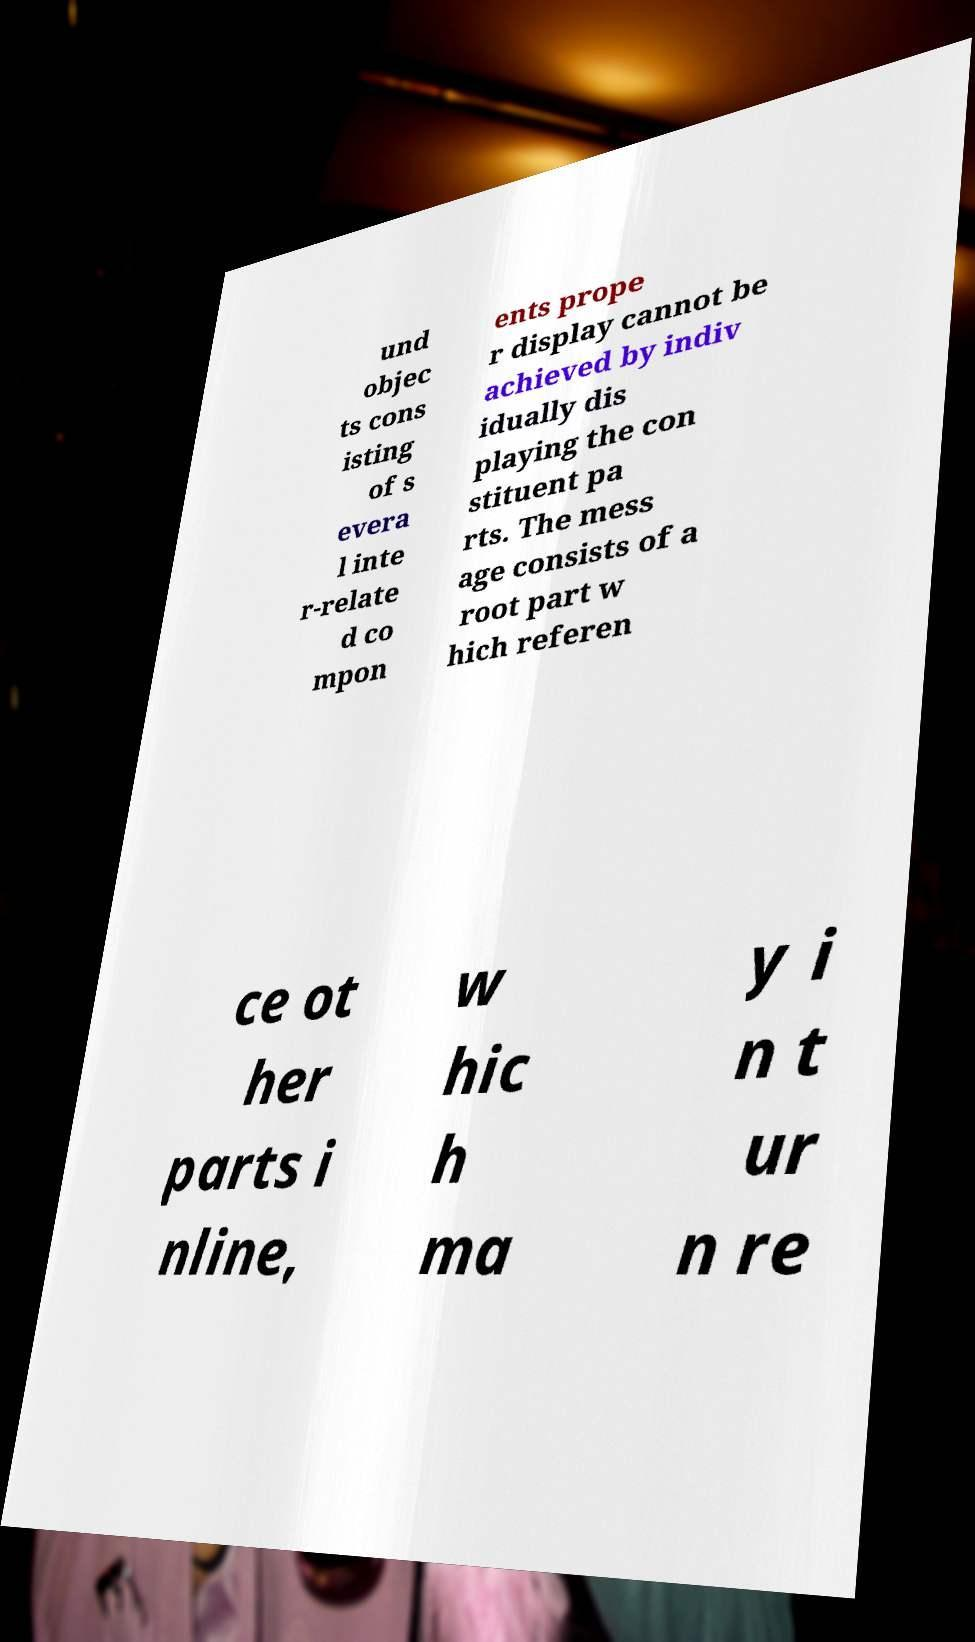Please identify and transcribe the text found in this image. und objec ts cons isting of s evera l inte r-relate d co mpon ents prope r display cannot be achieved by indiv idually dis playing the con stituent pa rts. The mess age consists of a root part w hich referen ce ot her parts i nline, w hic h ma y i n t ur n re 